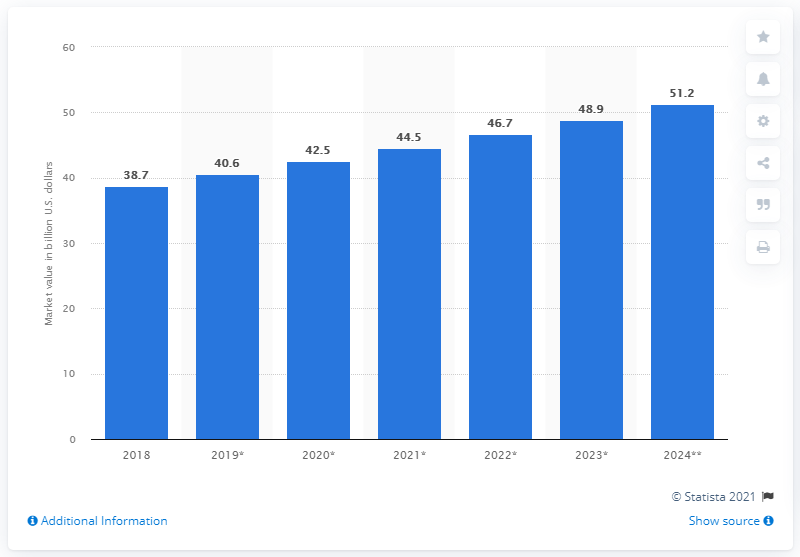Highlight a few significant elements in this photo. In 2019, the global yogurt market was valued at approximately 40.6 billion dollars. The global yogurt market is expected to reach a forecasted value of $51.2 billion by 2024. 